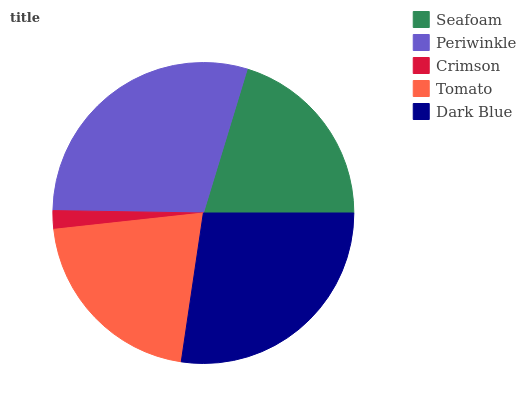Is Crimson the minimum?
Answer yes or no. Yes. Is Periwinkle the maximum?
Answer yes or no. Yes. Is Periwinkle the minimum?
Answer yes or no. No. Is Crimson the maximum?
Answer yes or no. No. Is Periwinkle greater than Crimson?
Answer yes or no. Yes. Is Crimson less than Periwinkle?
Answer yes or no. Yes. Is Crimson greater than Periwinkle?
Answer yes or no. No. Is Periwinkle less than Crimson?
Answer yes or no. No. Is Tomato the high median?
Answer yes or no. Yes. Is Tomato the low median?
Answer yes or no. Yes. Is Dark Blue the high median?
Answer yes or no. No. Is Crimson the low median?
Answer yes or no. No. 